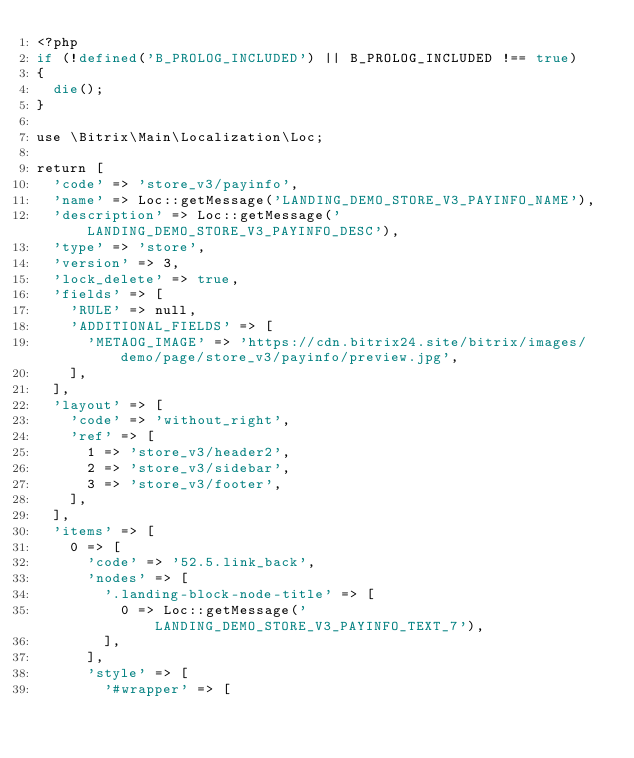<code> <loc_0><loc_0><loc_500><loc_500><_PHP_><?php
if (!defined('B_PROLOG_INCLUDED') || B_PROLOG_INCLUDED !== true)
{
	die();
}

use \Bitrix\Main\Localization\Loc;

return [
	'code' => 'store_v3/payinfo',
	'name' => Loc::getMessage('LANDING_DEMO_STORE_V3_PAYINFO_NAME'),
	'description' => Loc::getMessage('LANDING_DEMO_STORE_V3_PAYINFO_DESC'),
	'type' => 'store',
	'version' => 3,
	'lock_delete' => true,
	'fields' => [
		'RULE' => null,
		'ADDITIONAL_FIELDS' => [
			'METAOG_IMAGE' => 'https://cdn.bitrix24.site/bitrix/images/demo/page/store_v3/payinfo/preview.jpg',
		],
	],
	'layout' => [
		'code' => 'without_right',
		'ref' => [
			1 => 'store_v3/header2',
			2 => 'store_v3/sidebar',
			3 => 'store_v3/footer',
		],
	],
	'items' => [
		0 => [
			'code' => '52.5.link_back',
			'nodes' => [
				'.landing-block-node-title' => [
					0 => Loc::getMessage('LANDING_DEMO_STORE_V3_PAYINFO_TEXT_7'),
				],
			],
			'style' => [
				'#wrapper' => [</code> 